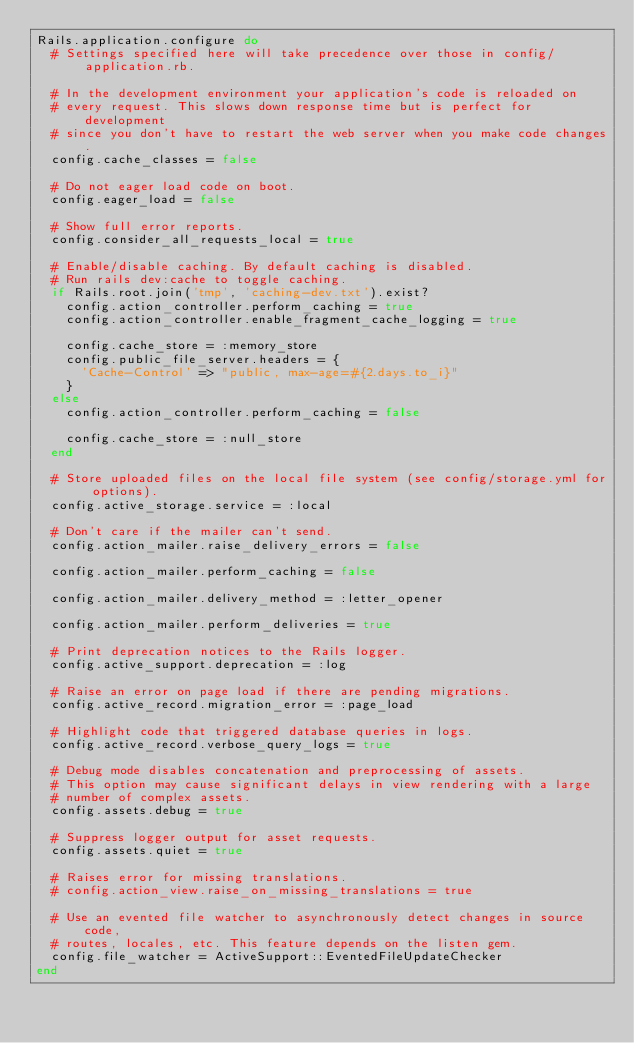Convert code to text. <code><loc_0><loc_0><loc_500><loc_500><_Ruby_>Rails.application.configure do
  # Settings specified here will take precedence over those in config/application.rb.

  # In the development environment your application's code is reloaded on
  # every request. This slows down response time but is perfect for development
  # since you don't have to restart the web server when you make code changes.
  config.cache_classes = false

  # Do not eager load code on boot.
  config.eager_load = false

  # Show full error reports.
  config.consider_all_requests_local = true

  # Enable/disable caching. By default caching is disabled.
  # Run rails dev:cache to toggle caching.
  if Rails.root.join('tmp', 'caching-dev.txt').exist?
    config.action_controller.perform_caching = true
    config.action_controller.enable_fragment_cache_logging = true

    config.cache_store = :memory_store
    config.public_file_server.headers = {
      'Cache-Control' => "public, max-age=#{2.days.to_i}"
    }
  else
    config.action_controller.perform_caching = false

    config.cache_store = :null_store
  end

  # Store uploaded files on the local file system (see config/storage.yml for options).
  config.active_storage.service = :local

  # Don't care if the mailer can't send.
  config.action_mailer.raise_delivery_errors = false

  config.action_mailer.perform_caching = false

  config.action_mailer.delivery_method = :letter_opener
  
  config.action_mailer.perform_deliveries = true

  # Print deprecation notices to the Rails logger.
  config.active_support.deprecation = :log

  # Raise an error on page load if there are pending migrations.
  config.active_record.migration_error = :page_load

  # Highlight code that triggered database queries in logs.
  config.active_record.verbose_query_logs = true

  # Debug mode disables concatenation and preprocessing of assets.
  # This option may cause significant delays in view rendering with a large
  # number of complex assets.
  config.assets.debug = true

  # Suppress logger output for asset requests.
  config.assets.quiet = true

  # Raises error for missing translations.
  # config.action_view.raise_on_missing_translations = true

  # Use an evented file watcher to asynchronously detect changes in source code,
  # routes, locales, etc. This feature depends on the listen gem.
  config.file_watcher = ActiveSupport::EventedFileUpdateChecker
end
</code> 